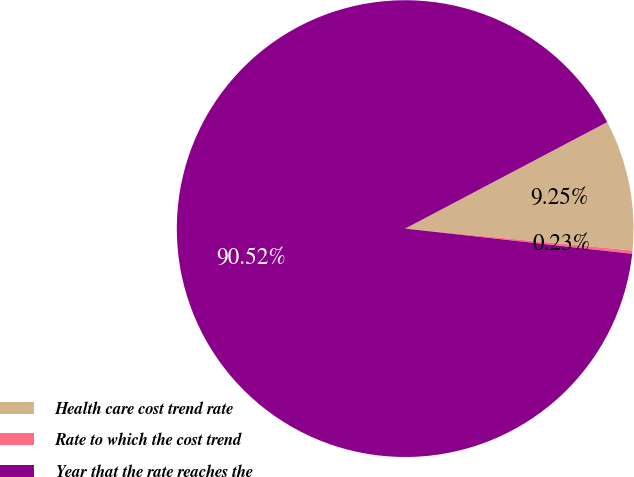Convert chart to OTSL. <chart><loc_0><loc_0><loc_500><loc_500><pie_chart><fcel>Health care cost trend rate<fcel>Rate to which the cost trend<fcel>Year that the rate reaches the<nl><fcel>9.25%<fcel>0.23%<fcel>90.52%<nl></chart> 